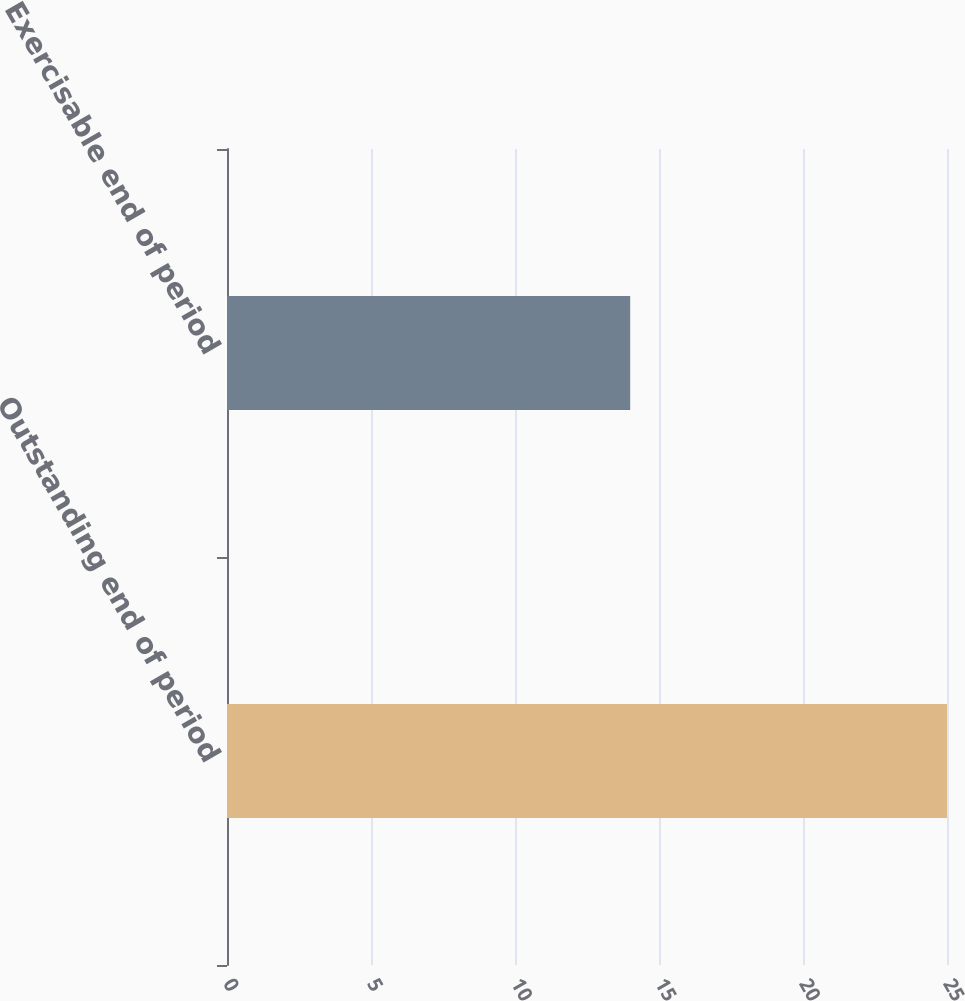Convert chart to OTSL. <chart><loc_0><loc_0><loc_500><loc_500><bar_chart><fcel>Outstanding end of period<fcel>Exercisable end of period<nl><fcel>25<fcel>14<nl></chart> 